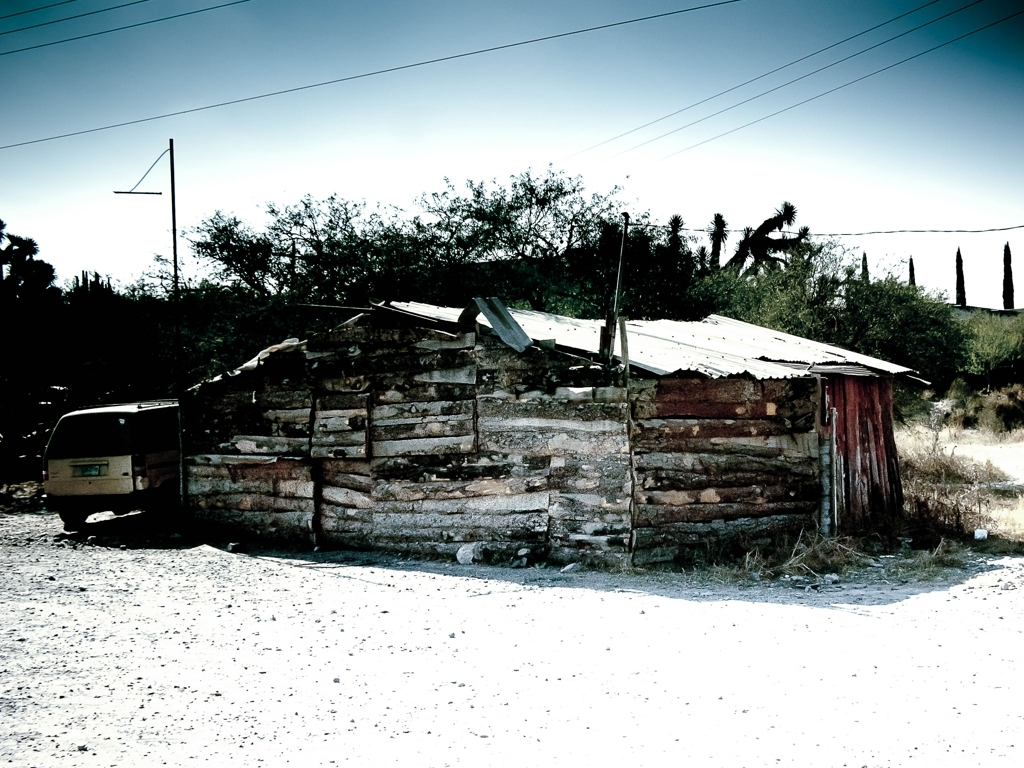Is the sharpness of the image average? The sharpness of the image may be perceived as average by some due to the moderate level of detail present. However, certain areas, such as the edges of the structure and the foliage, exhibit a softer focus which may lead some viewers to consider the sharpness less than average. 